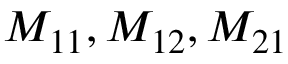Convert formula to latex. <formula><loc_0><loc_0><loc_500><loc_500>M _ { 1 1 } , M _ { 1 2 } , M _ { 2 1 }</formula> 